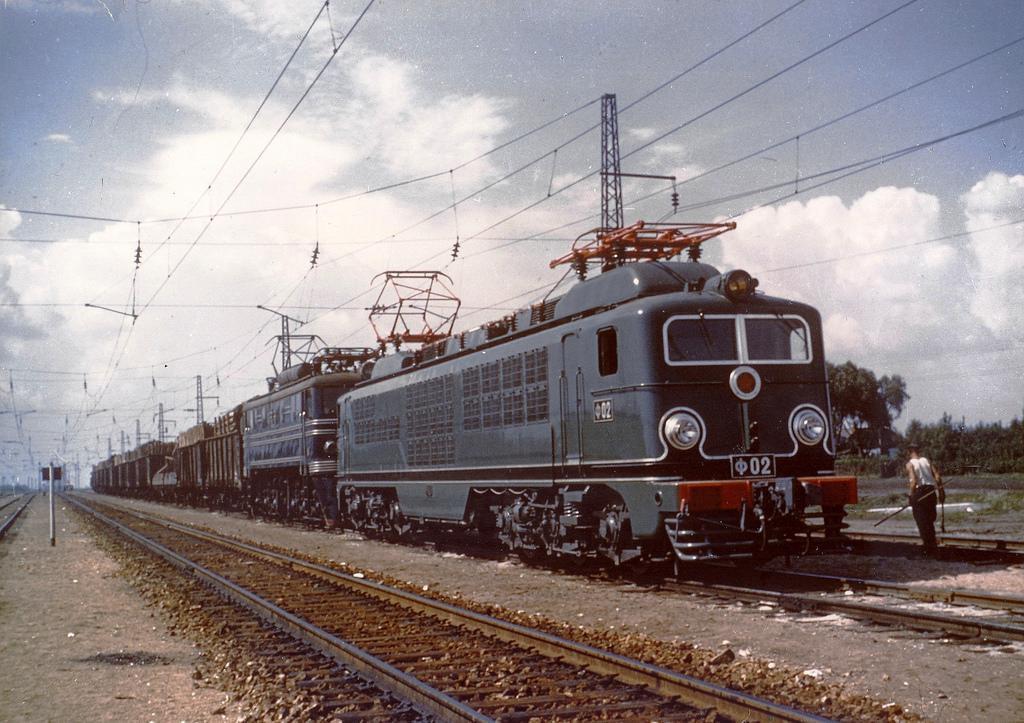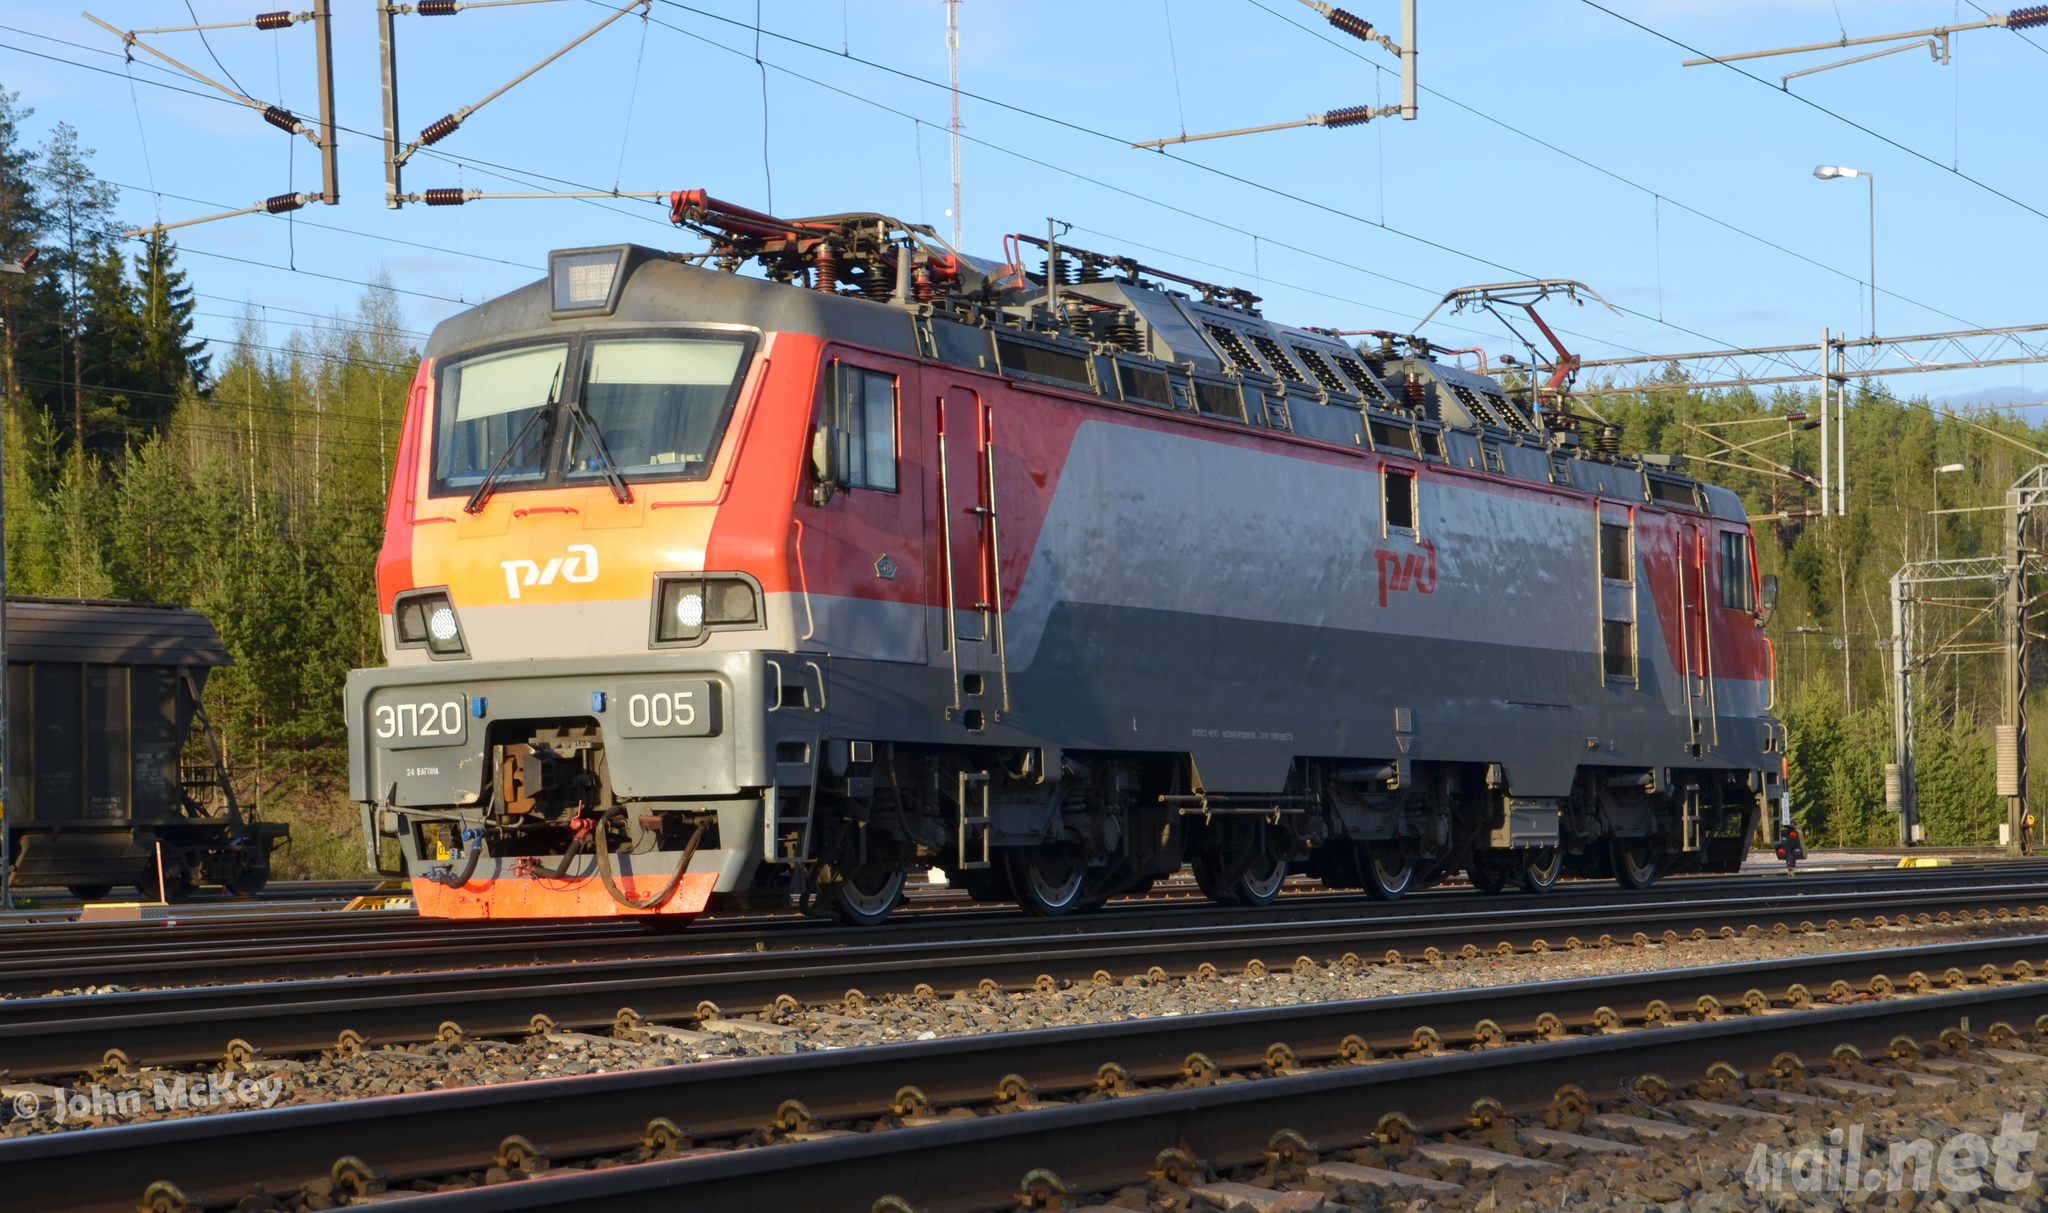The first image is the image on the left, the second image is the image on the right. Analyze the images presented: Is the assertion "Both trains are facing and traveling to the right." valid? Answer yes or no. No. The first image is the image on the left, the second image is the image on the right. Analyze the images presented: Is the assertion "An image shows a dark green train with bright orange stripes across the front." valid? Answer yes or no. No. 